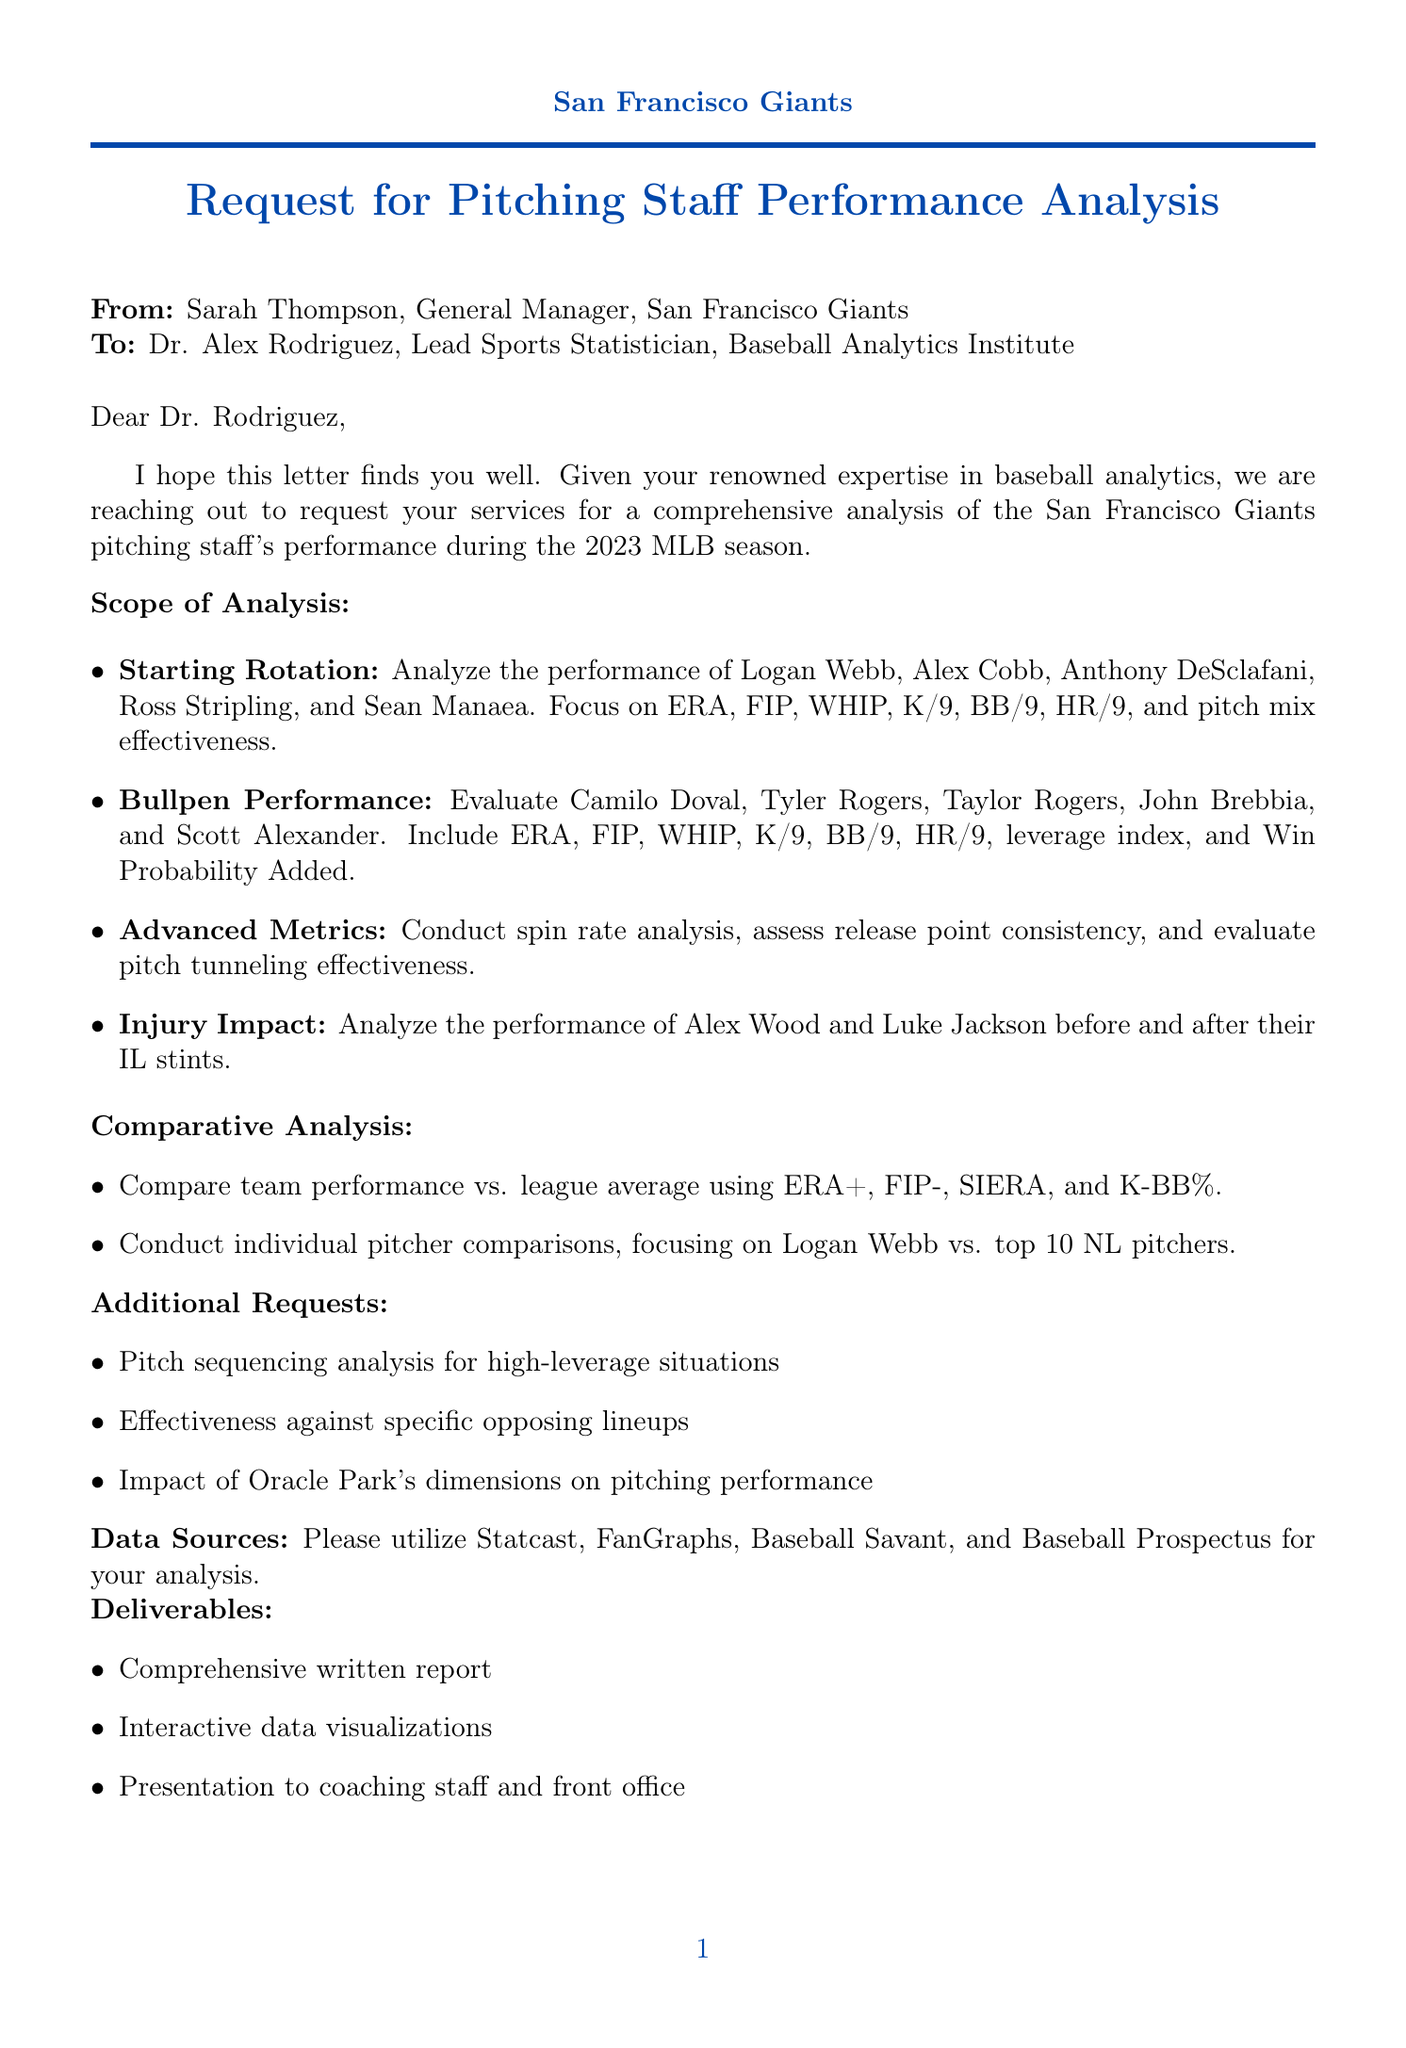What is the name of the sender? The sender's name is Sarah Thompson, who is the General Manager of the San Francisco Giants.
Answer: Sarah Thompson What is the focus area of the analysis requested? The analysis is focused on the pitching staff performance of the San Francisco Giants during the 2023 MLB season.
Answer: Pitching staff performance analysis Which players are included in the starting rotation analysis? The players included in the starting rotation analysis are Logan Webb, Alex Cobb, Anthony DeSclafani, Ross Stripling, and Sean Manaea.
Answer: Logan Webb, Alex Cobb, Anthony DeSclafani, Ross Stripling, Sean Manaea What specific metric is requested for bullpen performance? The metrics requested for bullpen performance include ERA, FIP, WHIP, K/9, BB/9, HR/9, leverage index, and Win Probability Added.
Answer: ERA, FIP, WHIP, K/9, BB/9, HR/9, leverage index, Win Probability Added What is the deadline for delivering the analysis? The deadline for delivering the analysis is December 15, 2023.
Answer: December 15, 2023 What additional analysis is requested for high-leverage situations? The additional analysis requested is pitch sequencing analysis for high-leverage situations.
Answer: Pitch sequencing analysis How much is the budget allocated for this analysis? The budget allocated for this analysis is $75,000.
Answer: $75,000 What type of deliverables are expected from the analysis? The expected deliverables include a comprehensive written report, interactive data visualizations, and a presentation to the coaching staff and front office.
Answer: Comprehensive written report, interactive data visualizations, presentation What future collaboration area is mentioned? The letter mentions potential future collaboration on pitch development strategies for the 2024 preseason.
Answer: Pitch development strategies 